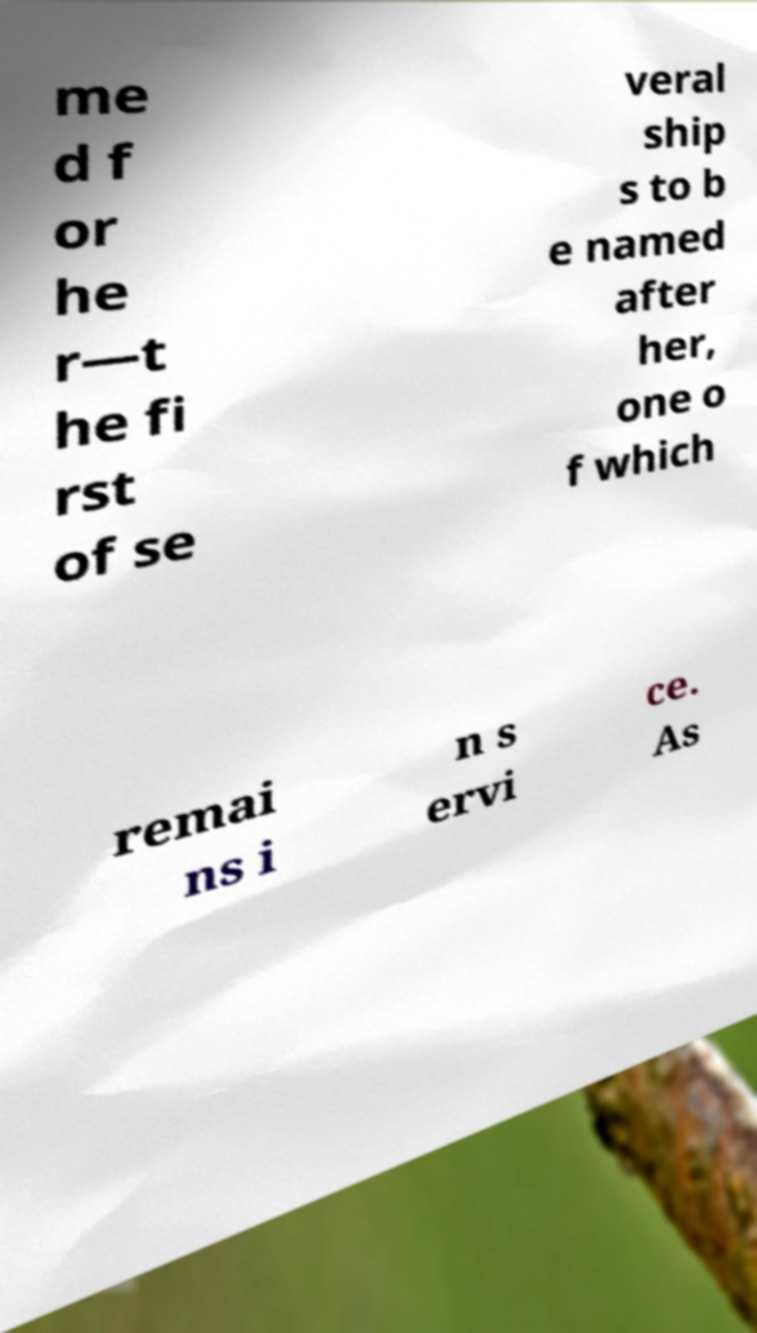There's text embedded in this image that I need extracted. Can you transcribe it verbatim? me d f or he r—t he fi rst of se veral ship s to b e named after her, one o f which remai ns i n s ervi ce. As 